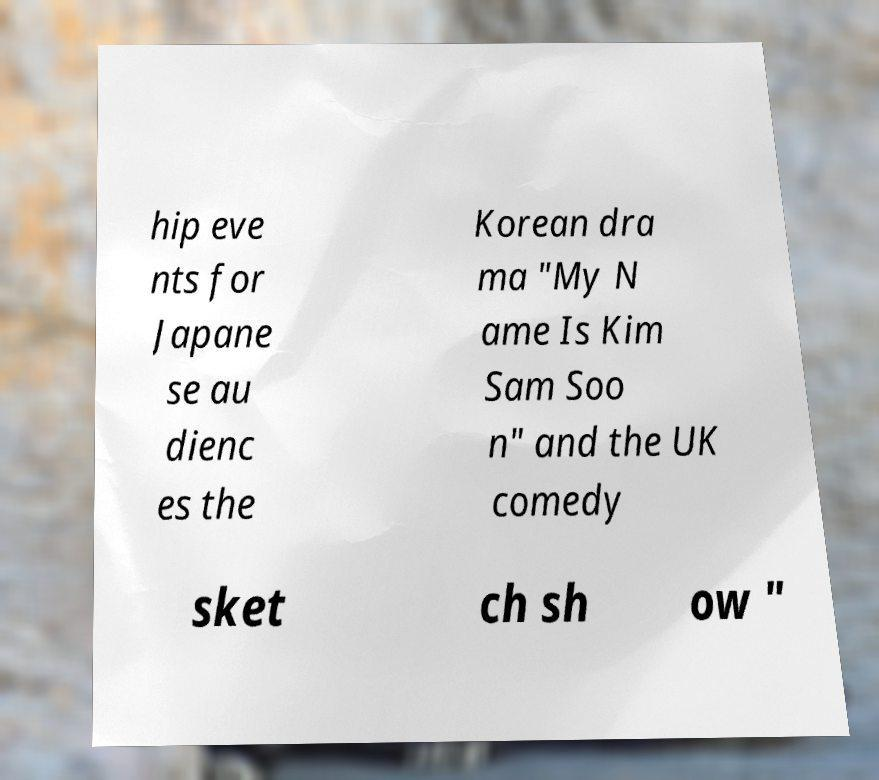What messages or text are displayed in this image? I need them in a readable, typed format. hip eve nts for Japane se au dienc es the Korean dra ma "My N ame Is Kim Sam Soo n" and the UK comedy sket ch sh ow " 